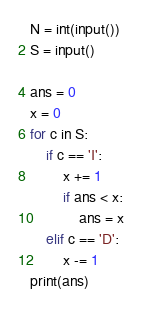<code> <loc_0><loc_0><loc_500><loc_500><_Python_>N = int(input())
S = input()

ans = 0
x = 0
for c in S:
    if c == 'I':
        x += 1
        if ans < x:
            ans = x
    elif c == 'D':
        x -= 1
print(ans)</code> 